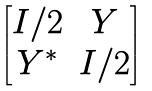Convert formula to latex. <formula><loc_0><loc_0><loc_500><loc_500>\begin{bmatrix} I / 2 & Y \\ Y ^ { * } & I / 2 \end{bmatrix}</formula> 